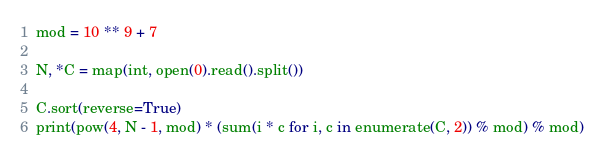Convert code to text. <code><loc_0><loc_0><loc_500><loc_500><_Python_>mod = 10 ** 9 + 7

N, *C = map(int, open(0).read().split())

C.sort(reverse=True)
print(pow(4, N - 1, mod) * (sum(i * c for i, c in enumerate(C, 2)) % mod) % mod)</code> 